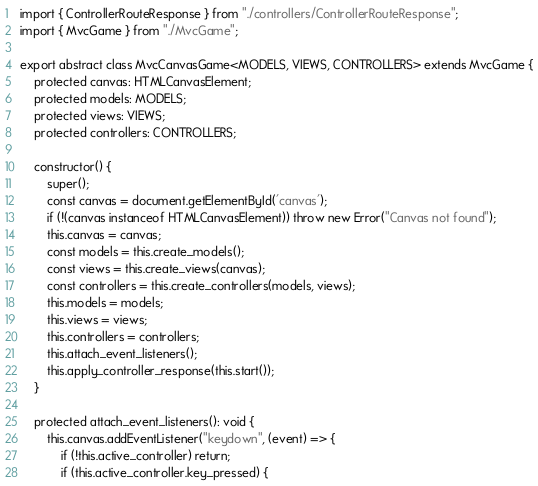<code> <loc_0><loc_0><loc_500><loc_500><_TypeScript_>import { ControllerRouteResponse } from "./controllers/ControllerRouteResponse";
import { MvcGame } from "./MvcGame";

export abstract class MvcCanvasGame<MODELS, VIEWS, CONTROLLERS> extends MvcGame {
    protected canvas: HTMLCanvasElement;
    protected models: MODELS;
    protected views: VIEWS;
    protected controllers: CONTROLLERS;

    constructor() {
        super();
        const canvas = document.getElementById('canvas');
        if (!(canvas instanceof HTMLCanvasElement)) throw new Error("Canvas not found");
        this.canvas = canvas;
        const models = this.create_models();
        const views = this.create_views(canvas);
        const controllers = this.create_controllers(models, views);
        this.models = models;
        this.views = views;
        this.controllers = controllers;
        this.attach_event_listeners();
        this.apply_controller_response(this.start());
    }

    protected attach_event_listeners(): void {
        this.canvas.addEventListener("keydown", (event) => {
            if (!this.active_controller) return;
            if (this.active_controller.key_pressed) {</code> 